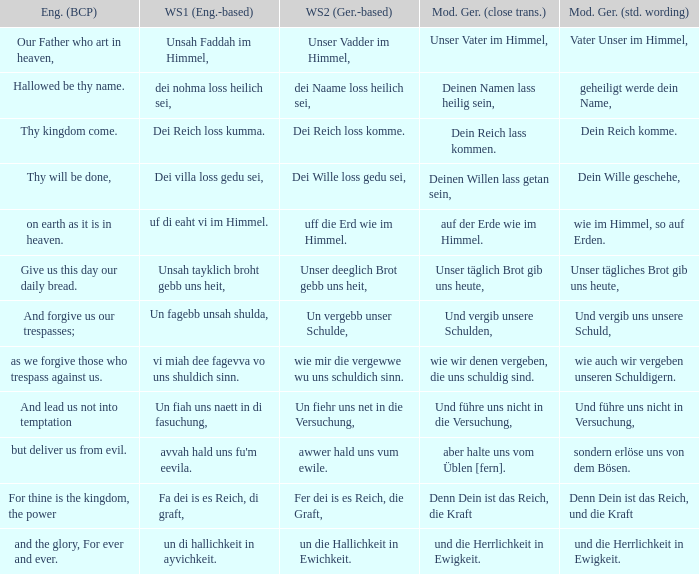Give me the full table as a dictionary. {'header': ['Eng. (BCP)', 'WS1 (Eng.-based)', 'WS2 (Ger.-based)', 'Mod. Ger. (close trans.)', 'Mod. Ger. (std. wording)'], 'rows': [['Our Father who art in heaven,', 'Unsah Faddah im Himmel,', 'Unser Vadder im Himmel,', 'Unser Vater im Himmel,', 'Vater Unser im Himmel,'], ['Hallowed be thy name.', 'dei nohma loss heilich sei,', 'dei Naame loss heilich sei,', 'Deinen Namen lass heilig sein,', 'geheiligt werde dein Name,'], ['Thy kingdom come.', 'Dei Reich loss kumma.', 'Dei Reich loss komme.', 'Dein Reich lass kommen.', 'Dein Reich komme.'], ['Thy will be done,', 'Dei villa loss gedu sei,', 'Dei Wille loss gedu sei,', 'Deinen Willen lass getan sein,', 'Dein Wille geschehe,'], ['on earth as it is in heaven.', 'uf di eaht vi im Himmel.', 'uff die Erd wie im Himmel.', 'auf der Erde wie im Himmel.', 'wie im Himmel, so auf Erden.'], ['Give us this day our daily bread.', 'Unsah tayklich broht gebb uns heit,', 'Unser deeglich Brot gebb uns heit,', 'Unser täglich Brot gib uns heute,', 'Unser tägliches Brot gib uns heute,'], ['And forgive us our trespasses;', 'Un fagebb unsah shulda,', 'Un vergebb unser Schulde,', 'Und vergib unsere Schulden,', 'Und vergib uns unsere Schuld,'], ['as we forgive those who trespass against us.', 'vi miah dee fagevva vo uns shuldich sinn.', 'wie mir die vergewwe wu uns schuldich sinn.', 'wie wir denen vergeben, die uns schuldig sind.', 'wie auch wir vergeben unseren Schuldigern.'], ['And lead us not into temptation', 'Un fiah uns naett in di fasuchung,', 'Un fiehr uns net in die Versuchung,', 'Und führe uns nicht in die Versuchung,', 'Und führe uns nicht in Versuchung,'], ['but deliver us from evil.', "avvah hald uns fu'm eevila.", 'awwer hald uns vum ewile.', 'aber halte uns vom Üblen [fern].', 'sondern erlöse uns von dem Bösen.'], ['For thine is the kingdom, the power', 'Fa dei is es Reich, di graft,', 'Fer dei is es Reich, die Graft,', 'Denn Dein ist das Reich, die Kraft', 'Denn Dein ist das Reich, und die Kraft'], ['and the glory, For ever and ever.', 'un di hallichkeit in ayvichkeit.', 'un die Hallichkeit in Ewichkeit.', 'und die Herrlichkeit in Ewigkeit.', 'und die Herrlichkeit in Ewigkeit.']]} What is the modern german standard wording for the german based writing system 2 phrase "wie mir die vergewwe wu uns schuldich sinn."? Wie auch wir vergeben unseren schuldigern. 